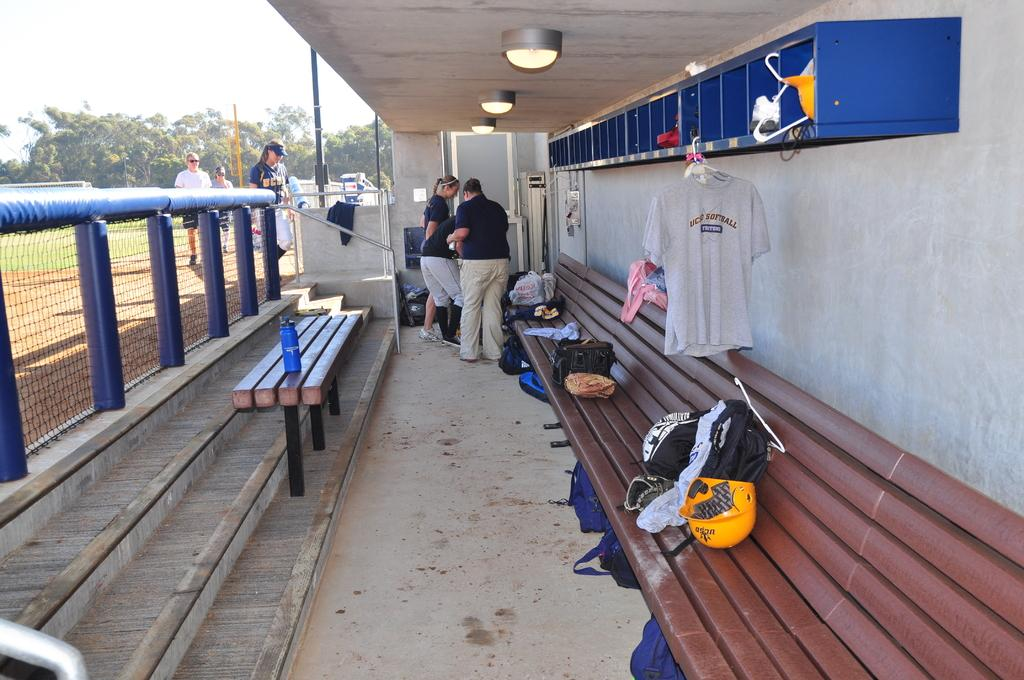How many people are in the image? There is a group of people in the image. What are some people wearing in the image? Some people are wearing helmets in the image. What can be seen besides the people in the image? There are bags or baggage, a bottle on a table, lights, and trees visible in the image. How many pigs are visible in the image? There are no pigs present in the image. What type of insurance is being discussed by the people in the image? There is no discussion about insurance in the image. 